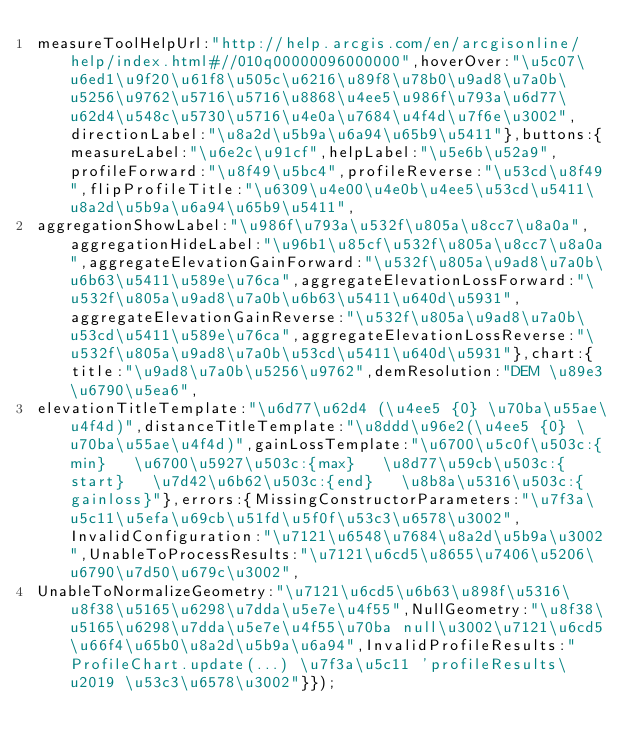Convert code to text. <code><loc_0><loc_0><loc_500><loc_500><_JavaScript_>measureToolHelpUrl:"http://help.arcgis.com/en/arcgisonline/help/index.html#//010q00000096000000",hoverOver:"\u5c07\u6ed1\u9f20\u61f8\u505c\u6216\u89f8\u78b0\u9ad8\u7a0b\u5256\u9762\u5716\u5716\u8868\u4ee5\u986f\u793a\u6d77\u62d4\u548c\u5730\u5716\u4e0a\u7684\u4f4d\u7f6e\u3002",directionLabel:"\u8a2d\u5b9a\u6a94\u65b9\u5411"},buttons:{measureLabel:"\u6e2c\u91cf",helpLabel:"\u5e6b\u52a9",profileForward:"\u8f49\u5bc4",profileReverse:"\u53cd\u8f49",flipProfileTitle:"\u6309\u4e00\u4e0b\u4ee5\u53cd\u5411\u8a2d\u5b9a\u6a94\u65b9\u5411",
aggregationShowLabel:"\u986f\u793a\u532f\u805a\u8cc7\u8a0a",aggregationHideLabel:"\u96b1\u85cf\u532f\u805a\u8cc7\u8a0a",aggregateElevationGainForward:"\u532f\u805a\u9ad8\u7a0b\u6b63\u5411\u589e\u76ca",aggregateElevationLossForward:"\u532f\u805a\u9ad8\u7a0b\u6b63\u5411\u640d\u5931",aggregateElevationGainReverse:"\u532f\u805a\u9ad8\u7a0b\u53cd\u5411\u589e\u76ca",aggregateElevationLossReverse:"\u532f\u805a\u9ad8\u7a0b\u53cd\u5411\u640d\u5931"},chart:{title:"\u9ad8\u7a0b\u5256\u9762",demResolution:"DEM \u89e3\u6790\u5ea6",
elevationTitleTemplate:"\u6d77\u62d4 (\u4ee5 {0} \u70ba\u55ae\u4f4d)",distanceTitleTemplate:"\u8ddd\u96e2(\u4ee5 {0} \u70ba\u55ae\u4f4d)",gainLossTemplate:"\u6700\u5c0f\u503c:{min}   \u6700\u5927\u503c:{max}   \u8d77\u59cb\u503c:{start}   \u7d42\u6b62\u503c:{end}   \u8b8a\u5316\u503c:{gainloss}"},errors:{MissingConstructorParameters:"\u7f3a\u5c11\u5efa\u69cb\u51fd\u5f0f\u53c3\u6578\u3002",InvalidConfiguration:"\u7121\u6548\u7684\u8a2d\u5b9a\u3002",UnableToProcessResults:"\u7121\u6cd5\u8655\u7406\u5206\u6790\u7d50\u679c\u3002",
UnableToNormalizeGeometry:"\u7121\u6cd5\u6b63\u898f\u5316\u8f38\u5165\u6298\u7dda\u5e7e\u4f55",NullGeometry:"\u8f38\u5165\u6298\u7dda\u5e7e\u4f55\u70ba null\u3002\u7121\u6cd5\u66f4\u65b0\u8a2d\u5b9a\u6a94",InvalidProfileResults:"ProfileChart.update(...) \u7f3a\u5c11 'profileResults\u2019 \u53c3\u6578\u3002"}});</code> 